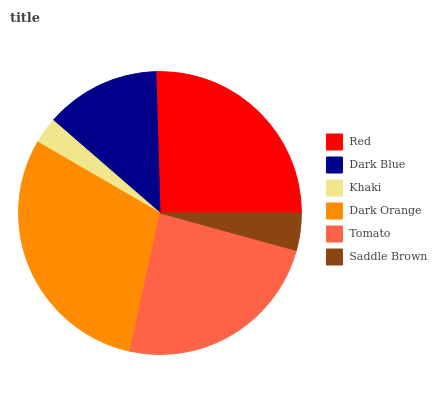Is Khaki the minimum?
Answer yes or no. Yes. Is Dark Orange the maximum?
Answer yes or no. Yes. Is Dark Blue the minimum?
Answer yes or no. No. Is Dark Blue the maximum?
Answer yes or no. No. Is Red greater than Dark Blue?
Answer yes or no. Yes. Is Dark Blue less than Red?
Answer yes or no. Yes. Is Dark Blue greater than Red?
Answer yes or no. No. Is Red less than Dark Blue?
Answer yes or no. No. Is Tomato the high median?
Answer yes or no. Yes. Is Dark Blue the low median?
Answer yes or no. Yes. Is Khaki the high median?
Answer yes or no. No. Is Saddle Brown the low median?
Answer yes or no. No. 